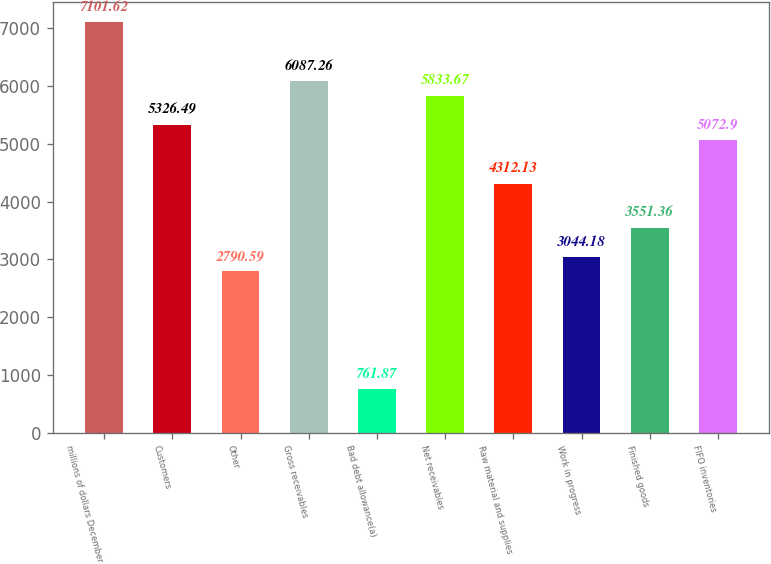Convert chart to OTSL. <chart><loc_0><loc_0><loc_500><loc_500><bar_chart><fcel>millions of dollars December<fcel>Customers<fcel>Other<fcel>Gross receivables<fcel>Bad debt allowance(a)<fcel>Net receivables<fcel>Raw material and supplies<fcel>Work in progress<fcel>Finished goods<fcel>FIFO inventories<nl><fcel>7101.62<fcel>5326.49<fcel>2790.59<fcel>6087.26<fcel>761.87<fcel>5833.67<fcel>4312.13<fcel>3044.18<fcel>3551.36<fcel>5072.9<nl></chart> 